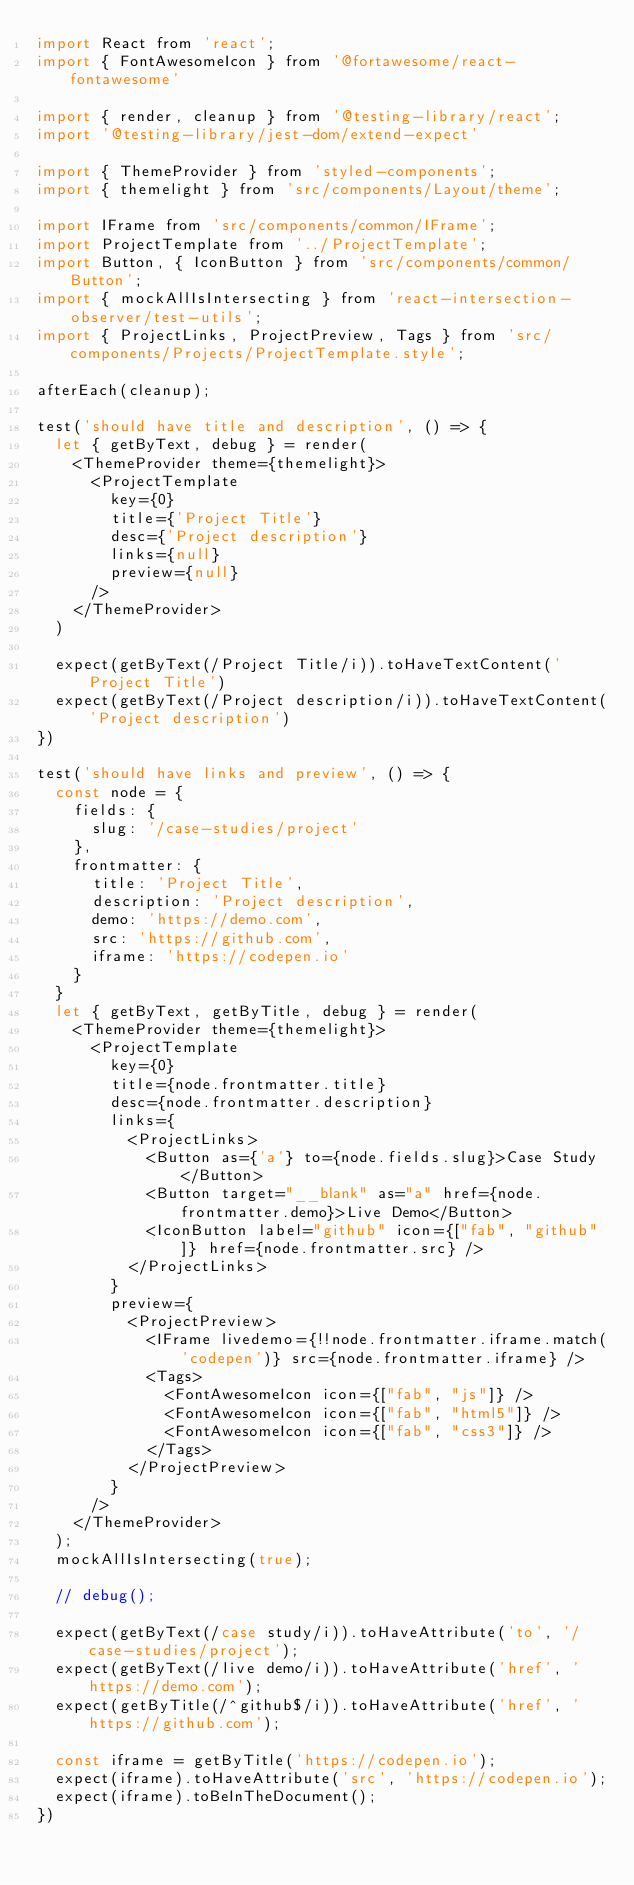Convert code to text. <code><loc_0><loc_0><loc_500><loc_500><_JavaScript_>import React from 'react';
import { FontAwesomeIcon } from '@fortawesome/react-fontawesome'

import { render, cleanup } from '@testing-library/react';
import '@testing-library/jest-dom/extend-expect'

import { ThemeProvider } from 'styled-components';
import { themelight } from 'src/components/Layout/theme';

import IFrame from 'src/components/common/IFrame';
import ProjectTemplate from '../ProjectTemplate';
import Button, { IconButton } from 'src/components/common/Button';
import { mockAllIsIntersecting } from 'react-intersection-observer/test-utils';
import { ProjectLinks, ProjectPreview, Tags } from 'src/components/Projects/ProjectTemplate.style';

afterEach(cleanup);

test('should have title and description', () => {
  let { getByText, debug } = render(
    <ThemeProvider theme={themelight}>
      <ProjectTemplate
        key={0}
        title={'Project Title'}
        desc={'Project description'}
        links={null}
        preview={null}
      />
    </ThemeProvider>
  )

  expect(getByText(/Project Title/i)).toHaveTextContent('Project Title')
  expect(getByText(/Project description/i)).toHaveTextContent('Project description')
})

test('should have links and preview', () => {
  const node = {
    fields: {
      slug: '/case-studies/project'
    },
    frontmatter: {
      title: 'Project Title',
      description: 'Project description',
      demo: 'https://demo.com',
      src: 'https://github.com',
      iframe: 'https://codepen.io'
    }
  }
  let { getByText, getByTitle, debug } = render(
    <ThemeProvider theme={themelight}>
      <ProjectTemplate
        key={0}
        title={node.frontmatter.title}
        desc={node.frontmatter.description}
        links={
          <ProjectLinks>
            <Button as={'a'} to={node.fields.slug}>Case Study</Button>
            <Button target="__blank" as="a" href={node.frontmatter.demo}>Live Demo</Button>
            <IconButton label="github" icon={["fab", "github"]} href={node.frontmatter.src} />
          </ProjectLinks>
        }
        preview={
          <ProjectPreview>
            <IFrame livedemo={!!node.frontmatter.iframe.match('codepen')} src={node.frontmatter.iframe} />
            <Tags>
              <FontAwesomeIcon icon={["fab", "js"]} />
              <FontAwesomeIcon icon={["fab", "html5"]} />
              <FontAwesomeIcon icon={["fab", "css3"]} />
            </Tags>
          </ProjectPreview>
        }
      />
    </ThemeProvider>
  );
  mockAllIsIntersecting(true);

  // debug();
  
  expect(getByText(/case study/i)).toHaveAttribute('to', '/case-studies/project');
  expect(getByText(/live demo/i)).toHaveAttribute('href', 'https://demo.com');
  expect(getByTitle(/^github$/i)).toHaveAttribute('href', 'https://github.com');

  const iframe = getByTitle('https://codepen.io');
  expect(iframe).toHaveAttribute('src', 'https://codepen.io');
  expect(iframe).toBeInTheDocument();
})</code> 